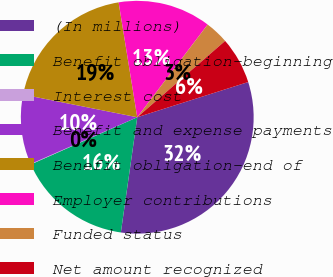Convert chart. <chart><loc_0><loc_0><loc_500><loc_500><pie_chart><fcel>(In millions)<fcel>Benefit obligation-beginning<fcel>Interest cost<fcel>Benefit and expense payments<fcel>Benefit obligation-end of<fcel>Employer contributions<fcel>Funded status<fcel>Net amount recognized<nl><fcel>32.14%<fcel>16.11%<fcel>0.07%<fcel>9.69%<fcel>19.32%<fcel>12.9%<fcel>3.28%<fcel>6.49%<nl></chart> 